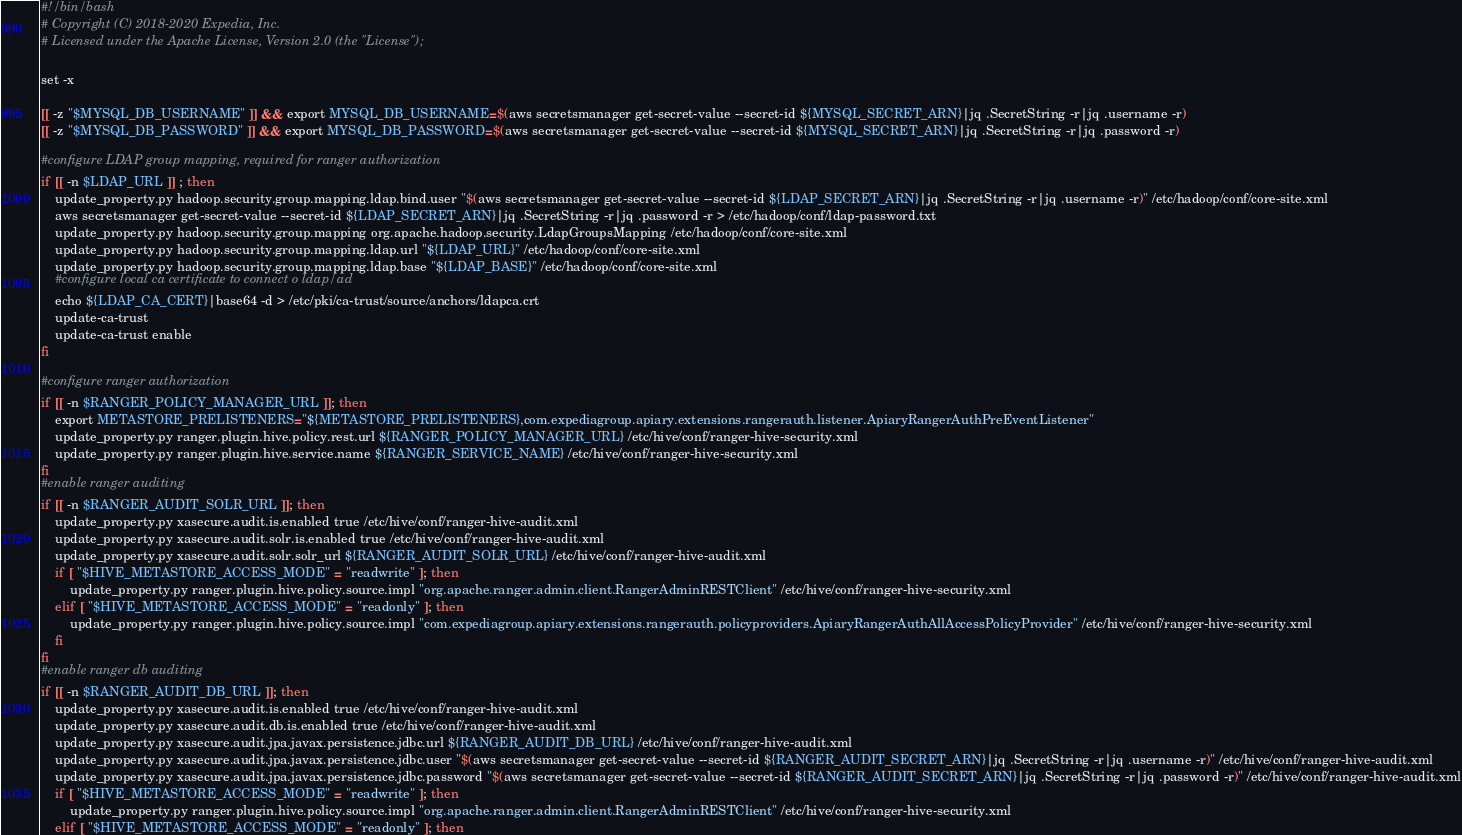Convert code to text. <code><loc_0><loc_0><loc_500><loc_500><_Bash_>#!/bin/bash
# Copyright (C) 2018-2020 Expedia, Inc.
# Licensed under the Apache License, Version 2.0 (the "License");

set -x

[[ -z "$MYSQL_DB_USERNAME" ]] && export MYSQL_DB_USERNAME=$(aws secretsmanager get-secret-value --secret-id ${MYSQL_SECRET_ARN}|jq .SecretString -r|jq .username -r)
[[ -z "$MYSQL_DB_PASSWORD" ]] && export MYSQL_DB_PASSWORD=$(aws secretsmanager get-secret-value --secret-id ${MYSQL_SECRET_ARN}|jq .SecretString -r|jq .password -r)

#configure LDAP group mapping, required for ranger authorization
if [[ -n $LDAP_URL ]] ; then
    update_property.py hadoop.security.group.mapping.ldap.bind.user "$(aws secretsmanager get-secret-value --secret-id ${LDAP_SECRET_ARN}|jq .SecretString -r|jq .username -r)" /etc/hadoop/conf/core-site.xml
    aws secretsmanager get-secret-value --secret-id ${LDAP_SECRET_ARN}|jq .SecretString -r|jq .password -r > /etc/hadoop/conf/ldap-password.txt
    update_property.py hadoop.security.group.mapping org.apache.hadoop.security.LdapGroupsMapping /etc/hadoop/conf/core-site.xml
    update_property.py hadoop.security.group.mapping.ldap.url "${LDAP_URL}" /etc/hadoop/conf/core-site.xml
    update_property.py hadoop.security.group.mapping.ldap.base "${LDAP_BASE}" /etc/hadoop/conf/core-site.xml
    #configure local ca certificate to connect o ldap/ad
    echo ${LDAP_CA_CERT}|base64 -d > /etc/pki/ca-trust/source/anchors/ldapca.crt
    update-ca-trust
    update-ca-trust enable
fi

#configure ranger authorization
if [[ -n $RANGER_POLICY_MANAGER_URL ]]; then
    export METASTORE_PRELISTENERS="${METASTORE_PRELISTENERS},com.expediagroup.apiary.extensions.rangerauth.listener.ApiaryRangerAuthPreEventListener"
    update_property.py ranger.plugin.hive.policy.rest.url ${RANGER_POLICY_MANAGER_URL} /etc/hive/conf/ranger-hive-security.xml
    update_property.py ranger.plugin.hive.service.name ${RANGER_SERVICE_NAME} /etc/hive/conf/ranger-hive-security.xml
fi
#enable ranger auditing
if [[ -n $RANGER_AUDIT_SOLR_URL ]]; then
    update_property.py xasecure.audit.is.enabled true /etc/hive/conf/ranger-hive-audit.xml
    update_property.py xasecure.audit.solr.is.enabled true /etc/hive/conf/ranger-hive-audit.xml
    update_property.py xasecure.audit.solr.solr_url ${RANGER_AUDIT_SOLR_URL} /etc/hive/conf/ranger-hive-audit.xml
    if [ "$HIVE_METASTORE_ACCESS_MODE" = "readwrite" ]; then
        update_property.py ranger.plugin.hive.policy.source.impl "org.apache.ranger.admin.client.RangerAdminRESTClient" /etc/hive/conf/ranger-hive-security.xml
    elif [ "$HIVE_METASTORE_ACCESS_MODE" = "readonly" ]; then
        update_property.py ranger.plugin.hive.policy.source.impl "com.expediagroup.apiary.extensions.rangerauth.policyproviders.ApiaryRangerAuthAllAccessPolicyProvider" /etc/hive/conf/ranger-hive-security.xml
    fi
fi
#enable ranger db auditing
if [[ -n $RANGER_AUDIT_DB_URL ]]; then
    update_property.py xasecure.audit.is.enabled true /etc/hive/conf/ranger-hive-audit.xml
    update_property.py xasecure.audit.db.is.enabled true /etc/hive/conf/ranger-hive-audit.xml
    update_property.py xasecure.audit.jpa.javax.persistence.jdbc.url ${RANGER_AUDIT_DB_URL} /etc/hive/conf/ranger-hive-audit.xml
    update_property.py xasecure.audit.jpa.javax.persistence.jdbc.user "$(aws secretsmanager get-secret-value --secret-id ${RANGER_AUDIT_SECRET_ARN}|jq .SecretString -r|jq .username -r)" /etc/hive/conf/ranger-hive-audit.xml
    update_property.py xasecure.audit.jpa.javax.persistence.jdbc.password "$(aws secretsmanager get-secret-value --secret-id ${RANGER_AUDIT_SECRET_ARN}|jq .SecretString -r|jq .password -r)" /etc/hive/conf/ranger-hive-audit.xml
    if [ "$HIVE_METASTORE_ACCESS_MODE" = "readwrite" ]; then
        update_property.py ranger.plugin.hive.policy.source.impl "org.apache.ranger.admin.client.RangerAdminRESTClient" /etc/hive/conf/ranger-hive-security.xml
    elif [ "$HIVE_METASTORE_ACCESS_MODE" = "readonly" ]; then</code> 